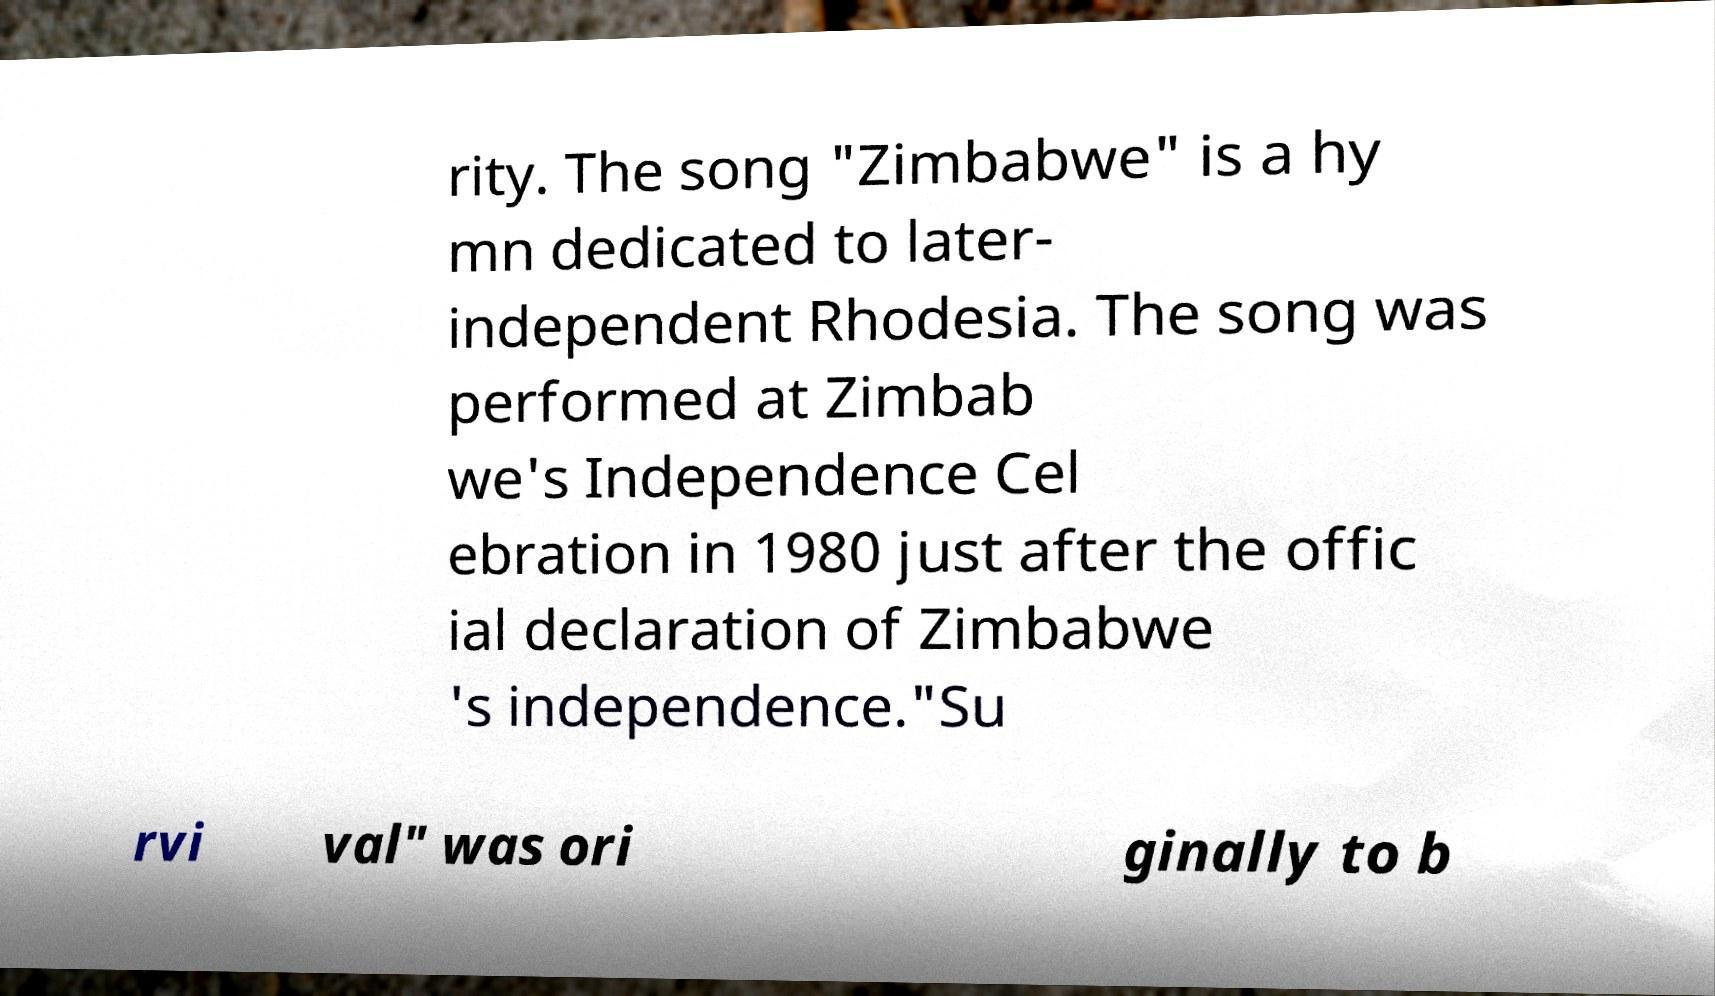Can you accurately transcribe the text from the provided image for me? rity. The song "Zimbabwe" is a hy mn dedicated to later- independent Rhodesia. The song was performed at Zimbab we's Independence Cel ebration in 1980 just after the offic ial declaration of Zimbabwe 's independence."Su rvi val" was ori ginally to b 